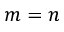<formula> <loc_0><loc_0><loc_500><loc_500>m = n</formula> 